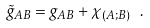<formula> <loc_0><loc_0><loc_500><loc_500>\tilde { g } _ { A B } = g _ { A B } + \chi _ { ( A ; B ) } \ .</formula> 